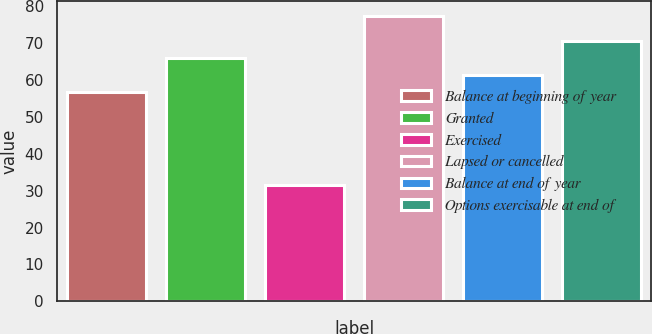Convert chart to OTSL. <chart><loc_0><loc_0><loc_500><loc_500><bar_chart><fcel>Balance at beginning of year<fcel>Granted<fcel>Exercised<fcel>Lapsed or cancelled<fcel>Balance at end of year<fcel>Options exercisable at end of<nl><fcel>56.74<fcel>65.9<fcel>31.49<fcel>77.33<fcel>61.32<fcel>70.48<nl></chart> 